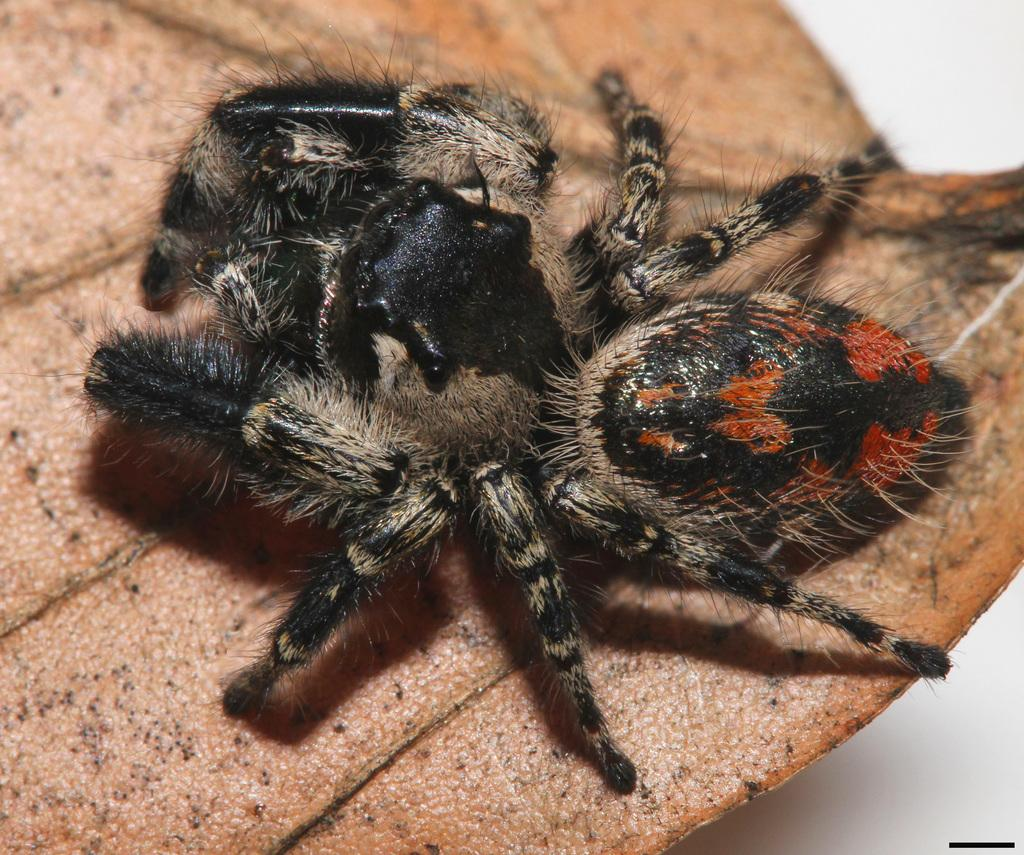What is present in the image? There is a spider in the image. Can you describe the spider's location in the image? The spider is on an object. What type of breakfast is the spider eating in the image? There is no breakfast present in the image, as it features a spider on an object. Can you tell me where the map is located in the image? There is no map present in the image. 